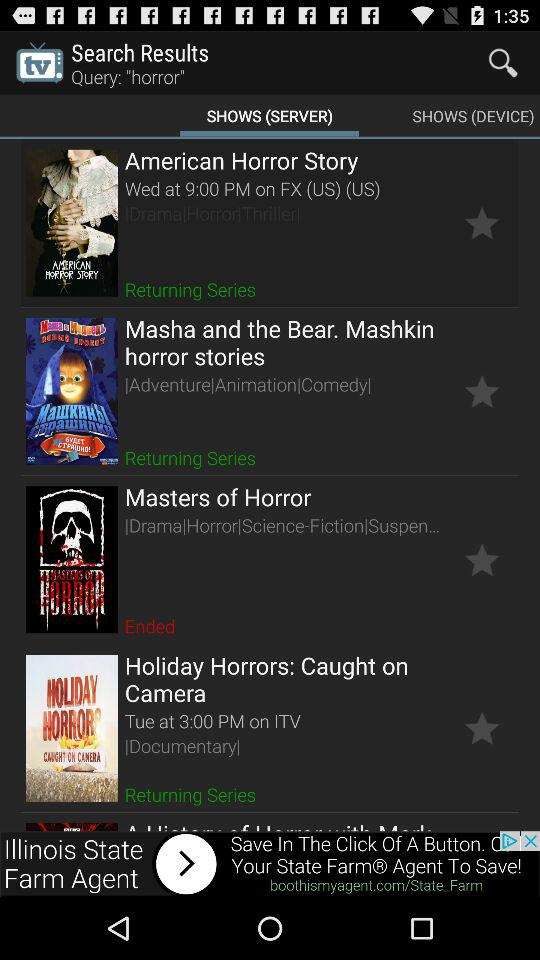What is the show time of "American Horror Story"? The show time is on Wednesday at 9 PM. 